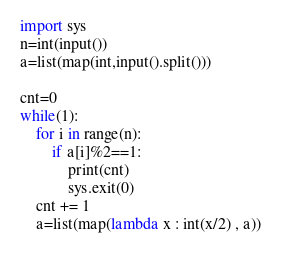<code> <loc_0><loc_0><loc_500><loc_500><_Python_>import sys
n=int(input())
a=list(map(int,input().split()))

cnt=0
while(1):
    for i in range(n):
        if a[i]%2==1:
            print(cnt)
            sys.exit(0)
    cnt += 1
    a=list(map(lambda x : int(x/2) , a))</code> 